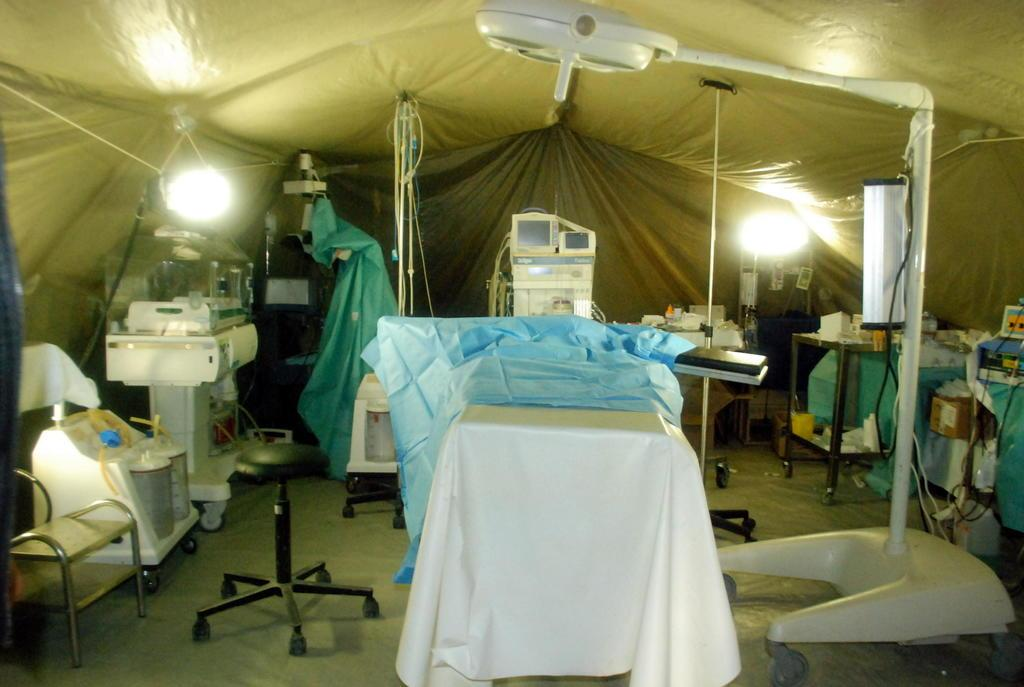What type of equipment can be seen in the foreground of the image? There are medical equipment in the foreground of the image. Where are the medical equipment located? The medical equipment is under a tent. What type of furniture is present in the image? There are chairs and tables in the image. What is on top of the tables? There are objects on the tables. What historical event is being commemorated in the image? There is no indication of a historical event being commemorated in the image. 